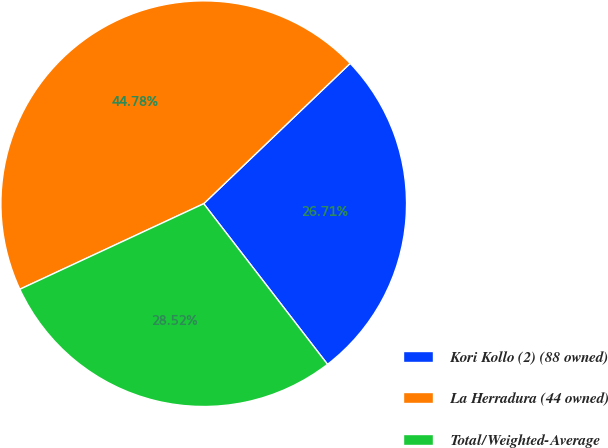Convert chart to OTSL. <chart><loc_0><loc_0><loc_500><loc_500><pie_chart><fcel>Kori Kollo (2) (88 owned)<fcel>La Herradura (44 owned)<fcel>Total/Weighted-Average<nl><fcel>26.71%<fcel>44.78%<fcel>28.52%<nl></chart> 